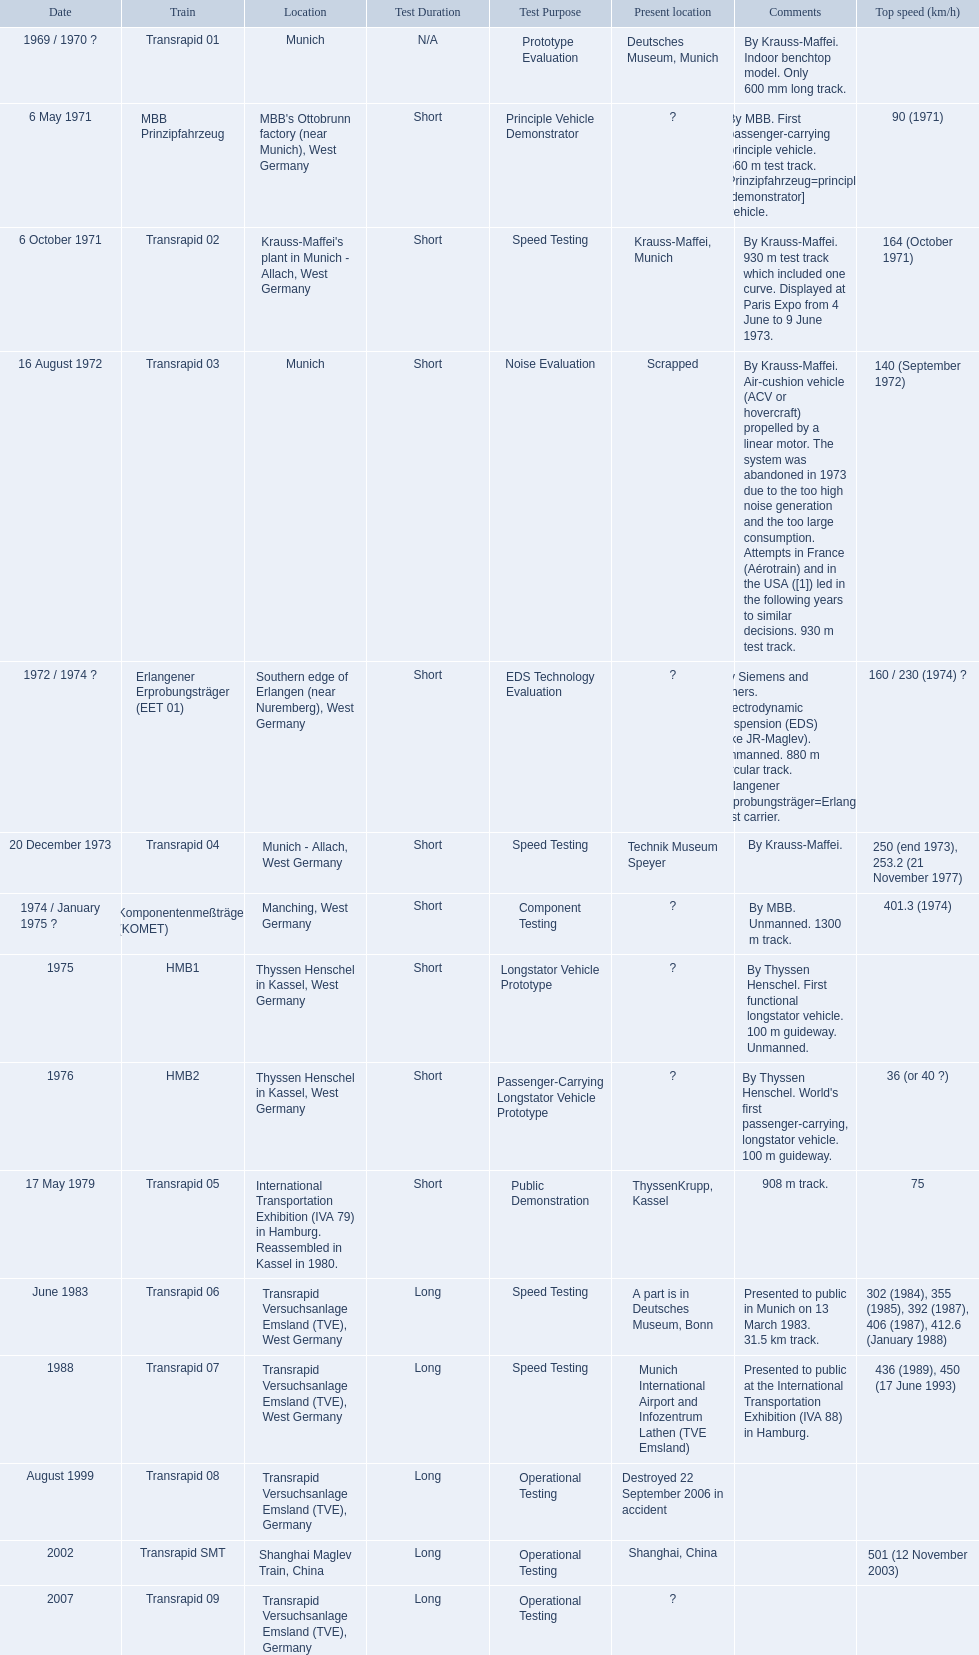What is the top speed reached by any trains shown here? 501 (12 November 2003). What train has reached a top speed of 501? Transrapid SMT. 